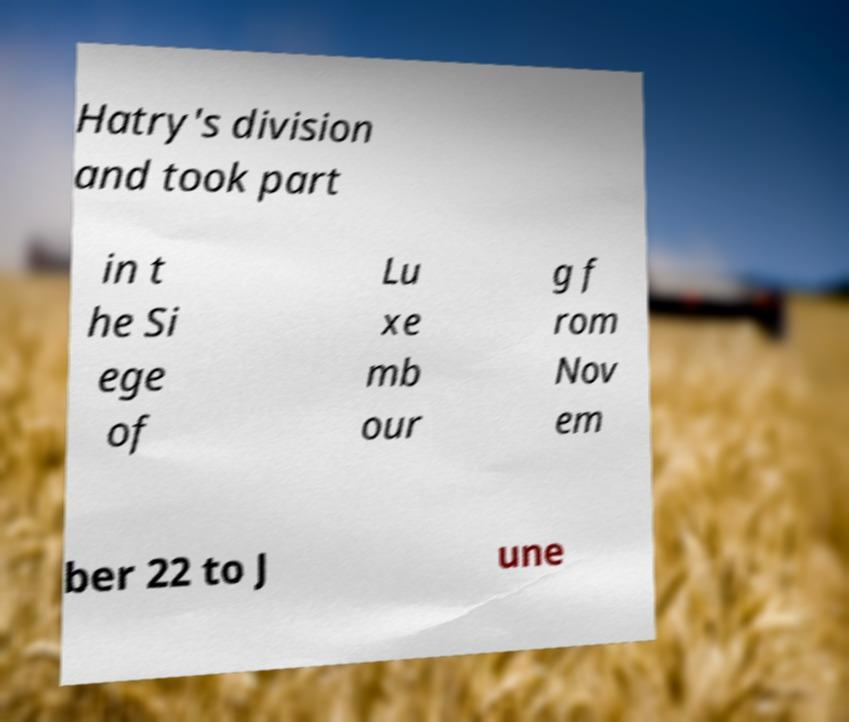Please identify and transcribe the text found in this image. Hatry's division and took part in t he Si ege of Lu xe mb our g f rom Nov em ber 22 to J une 